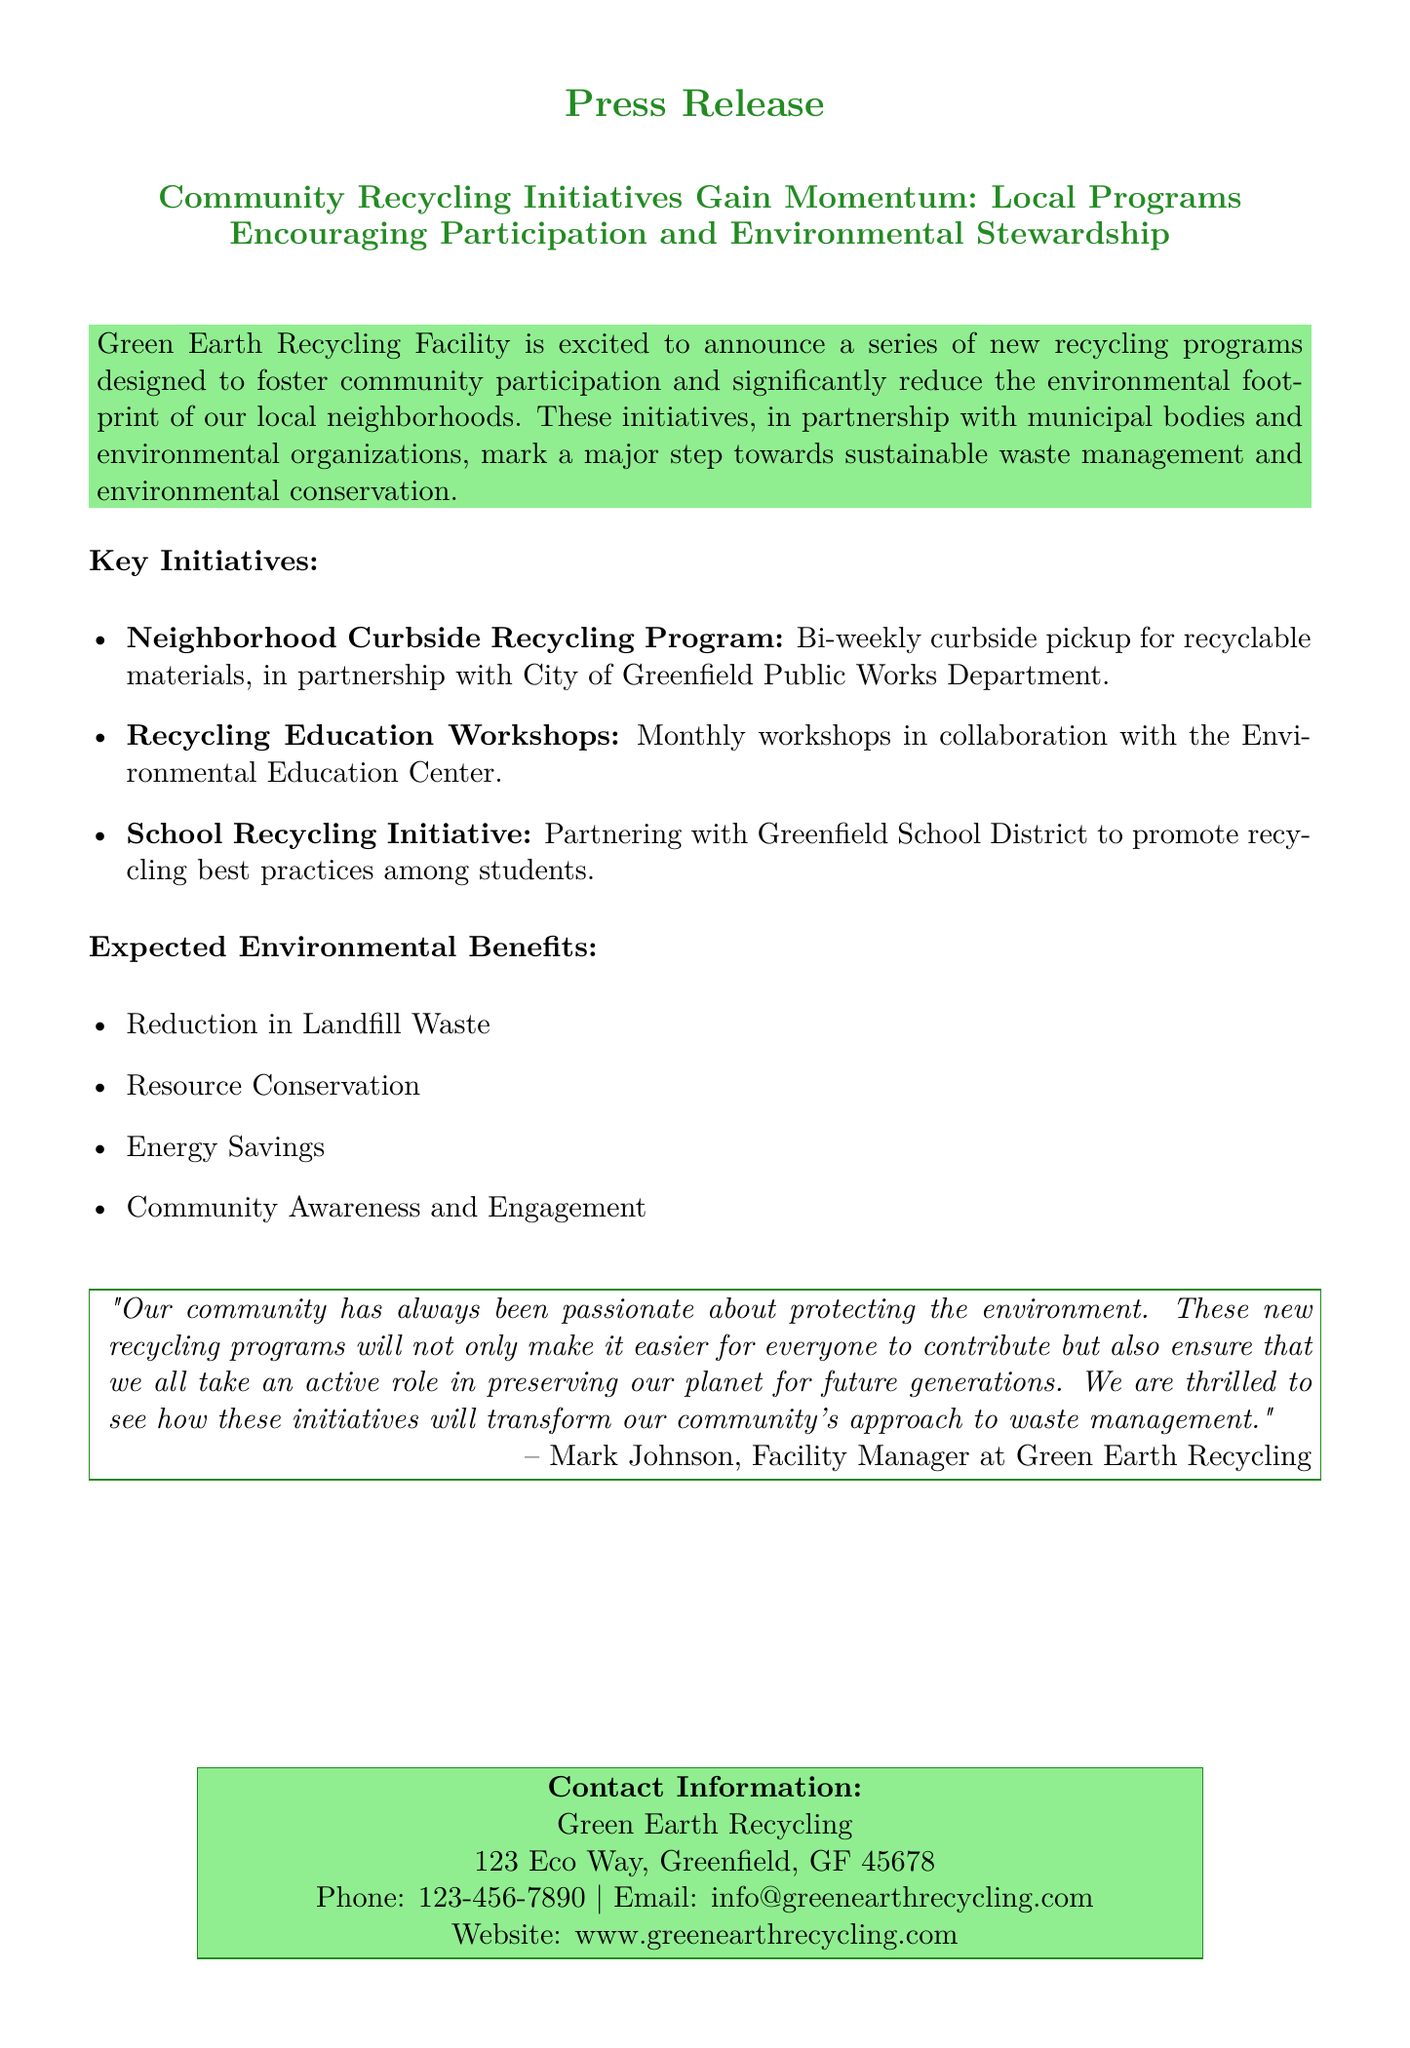What is the name of the facility announcing the new programs? The facility name is mentioned in the title of the press release as the organization behind the initiative.
Answer: Green Earth Recycling Facility What is the frequency of the curbside recycling pickup? The frequency of the curbside recycling pickup is specified in the key initiatives section.
Answer: Bi-weekly What organization is collaborating for the Recycling Education Workshops? The collaborating organization is stated in the key initiatives section.
Answer: Environmental Education Center What are the expected environmental benefits listed in the document? The benefits are outlined in a bullet list as follows.
Answer: Reduction in Landfill Waste, Resource Conservation, Energy Savings, Community Awareness and Engagement Who is the Facility Manager quoted in the press release? The identity of the Facility Manager is found in the quote section.
Answer: Mark Johnson What is the contact phone number for Green Earth Recycling? The contact phone number is provided at the end of the press release.
Answer: 123-456-7890 What is the address of Green Earth Recycling? The address is mentioned in the contact information section of the document.
Answer: 123 Eco Way, Greenfield, GF 45678 What kind of initiative is the School Recycling Initiative related to? The type of initiative is mentioned in the key initiatives section.
Answer: Promotion of recycling best practices among students What is the primary aim of the new recycling programs? The primary aim is described in the introductory paragraph.
Answer: Foster community participation and significantly reduce the environmental footprint 